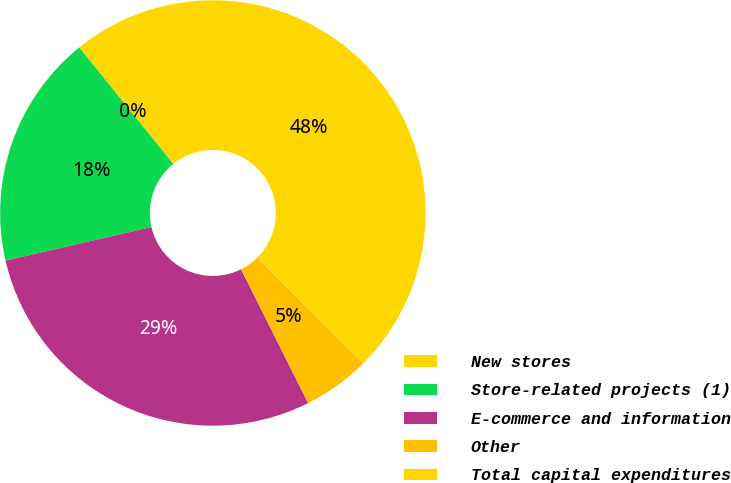<chart> <loc_0><loc_0><loc_500><loc_500><pie_chart><fcel>New stores<fcel>Store-related projects (1)<fcel>E-commerce and information<fcel>Other<fcel>Total capital expenditures<nl><fcel>0.37%<fcel>17.79%<fcel>28.8%<fcel>5.12%<fcel>47.92%<nl></chart> 